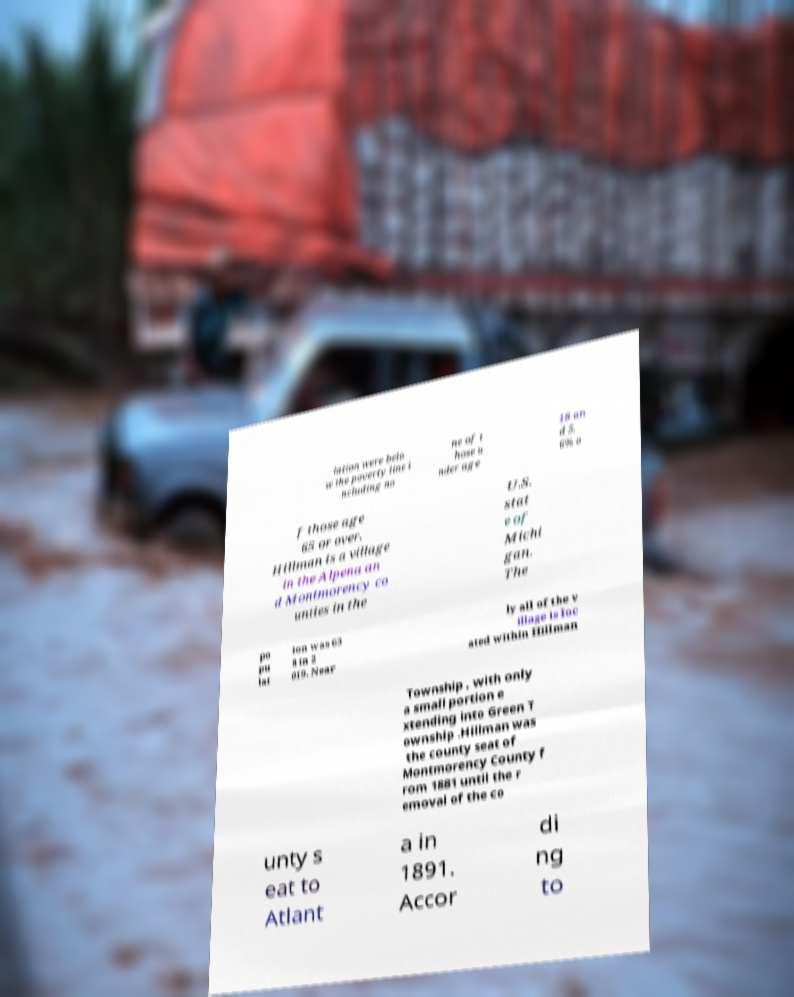Please identify and transcribe the text found in this image. lation were belo w the poverty line i ncluding no ne of t hose u nder age 18 an d 5. 6% o f those age 65 or over. Hillman is a village in the Alpena an d Montmorency co unties in the U.S. stat e of Michi gan. The po pu lat ion was 63 8 in 2 019. Near ly all of the v illage is loc ated within Hillman Township , with only a small portion e xtending into Green T ownship .Hillman was the county seat of Montmorency County f rom 1881 until the r emoval of the co unty s eat to Atlant a in 1891. Accor di ng to 